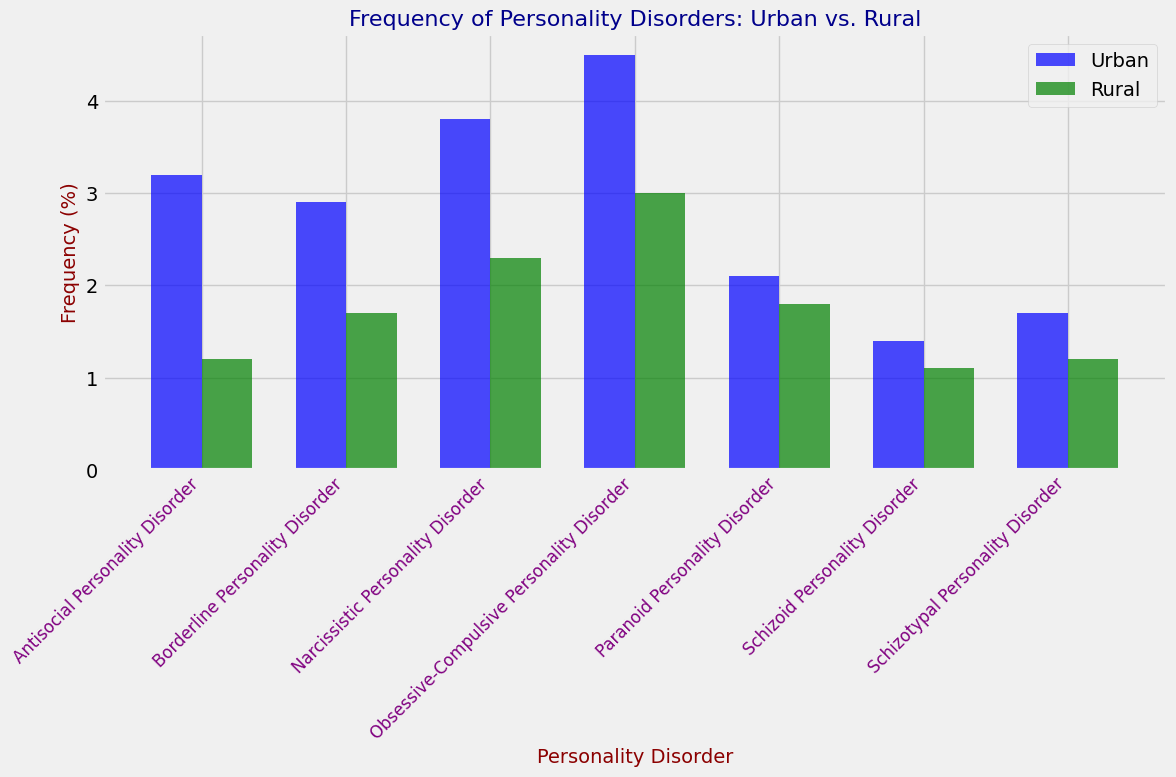Which personality disorder has the highest frequency in urban populations? Identify the tallest bar in the 'Urban' group, which is colored blue. The highest frequency corresponds to 'Obsessive-Compulsive Personality Disorder' with a value of 4.5%.
Answer: Obsessive-Compulsive Personality Disorder What is the difference in frequency of Antisocial Personality Disorder between urban and rural populations? Note the heights of the bars for Antisocial Personality Disorder in both groups. For urban populations, it is 3.2%, and for rural populations, it is 1.2%. Calculate the difference: 3.2% - 1.2% = 2%.
Answer: 2% Which personality disorder shows the smallest difference in frequency between urban and rural populations? Examine the bars for each disorder to find the one where the height difference between the urban and rural bars is the smallest. 'Schizoid Personality Disorder' has frequencies of 1.4% (urban) and 1.1% (rural), making the difference 0.3%.
Answer: Schizoid Personality Disorder Is the frequency of Narcissistic Personality Disorder higher in urban or rural populations? Compare the heights of the bars for Narcissistic Personality Disorder between urban and rural groups. The urban bar is 3.8%, and the rural bar is 2.3%, showing that the frequency is higher in urban populations.
Answer: Urban Which population, urban or rural, generally has higher frequencies of personality disorders? Compare the overall heights of the bars between the urban and rural groups. Most bars in the urban group are taller than those in the rural group, indicating higher frequencies of personality disorders in urban populations.
Answer: Urban What is the combined frequency of Paranoid Personality Disorder in both urban and rural populations? For Paranoid Personality Disorder, add the frequencies from both populations: 2.1% (urban) + 1.8% (rural) = 3.9%.
Answer: 3.9% How much more frequent is Obsessive-Compulsive Personality Disorder in urban populations compared to rural ones? Identify the heights for Obsessive-Compulsive Personality Disorder: 4.5% (urban) and 3.0% (rural). Subtract the rural frequency from the urban frequency: 4.5% - 3.0% = 1.5%.
Answer: 1.5% Which personality disorder has a higher frequency in rural than in urban populations? Check each personality disorder's bars to see if any are higher in the rural population compared to the urban one. None of the disorders have a higher frequency in rural populations.
Answer: None What is the average frequency of Borderline Personality Disorder across both populations? Add the frequencies for Borderline Personality Disorder in urban and rural populations and then divide by 2: (2.9% + 1.7%) / 2 = 2.3%.
Answer: 2.3% How does the frequency of Schizotypal Personality Disorder in urban populations compare to that in rural populations? Compare the heights of the bars for Schizotypal Personality Disorder: urban is 1.7% and rural is 1.2%. The urban frequency is higher.
Answer: Urban 